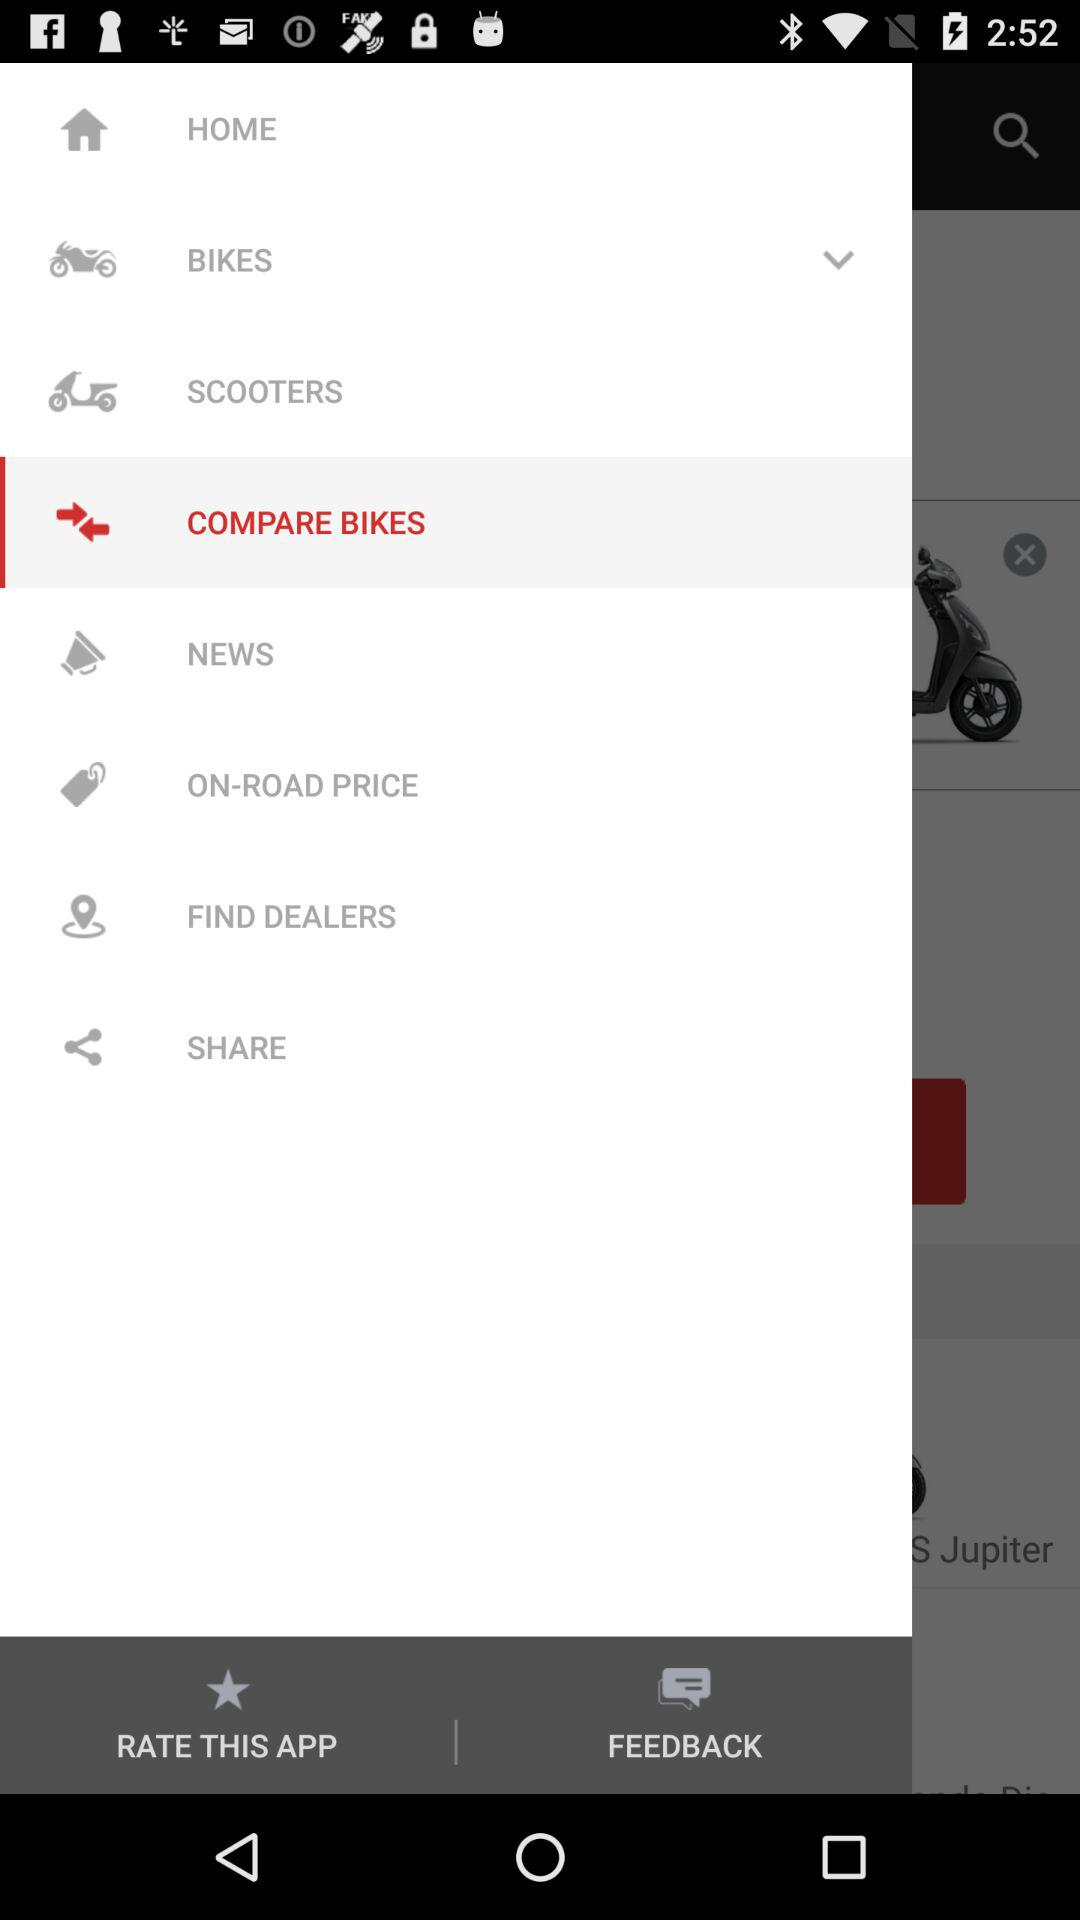Which is the selected tab? The selected tab is "COMPARE BIKES". 